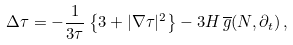Convert formula to latex. <formula><loc_0><loc_0><loc_500><loc_500>\Delta \tau = - \frac { 1 } { 3 \tau } \left \{ 3 + | \nabla \tau | ^ { 2 } \right \} - 3 H \, \overline { g } ( N , \partial _ { t } ) \, ,</formula> 